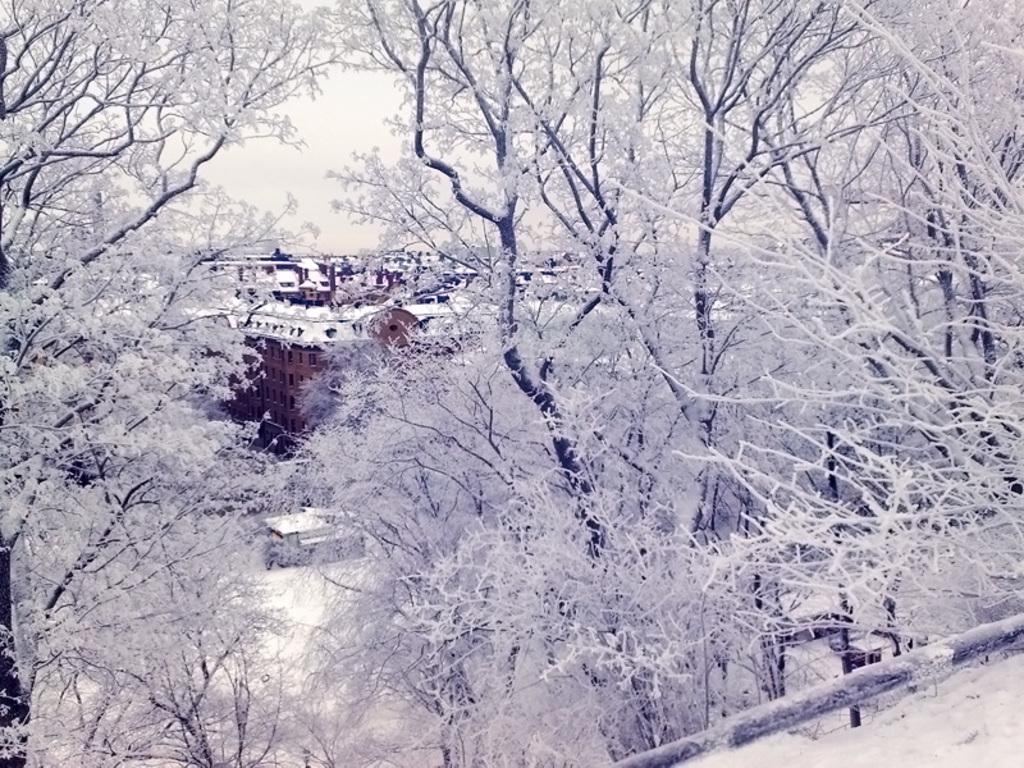What type of vegetation can be seen in the image? There are trees in the image. What is covering the trees? Snow is present on the trees. What can be seen behind the trees in the image? There are buildings visible behind the trees. What type of square underwear is hanging on the trees in the image? There is no underwear present in the image; it only features trees with snow on them and buildings in the background. 